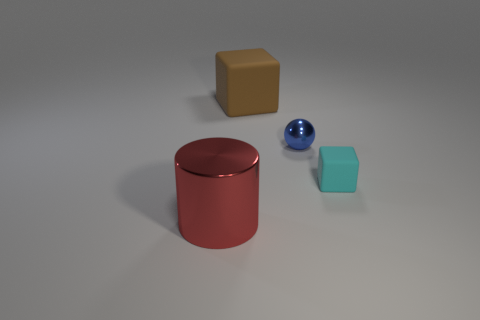There is a small thing that is on the right side of the tiny thing that is to the left of the cyan thing; what number of cyan matte things are to the right of it?
Ensure brevity in your answer.  0. Are there any tiny cyan rubber cubes on the left side of the small blue shiny object?
Keep it short and to the point. No. Is there any other thing that has the same color as the small metallic ball?
Your response must be concise. No. What number of cylinders are blue things or big brown rubber things?
Keep it short and to the point. 0. How many things are behind the cyan rubber block and in front of the brown block?
Give a very brief answer. 1. Is the number of small spheres that are to the left of the cylinder the same as the number of red objects that are right of the metal sphere?
Offer a very short reply. Yes. There is a metal object in front of the cyan matte block; is it the same shape as the big matte object?
Provide a short and direct response. No. What shape is the metallic object on the left side of the matte cube behind the thing that is to the right of the blue thing?
Offer a terse response. Cylinder. There is a thing that is behind the tiny cyan object and right of the big matte thing; what is its material?
Give a very brief answer. Metal. Is the number of cyan matte blocks less than the number of gray spheres?
Give a very brief answer. No. 